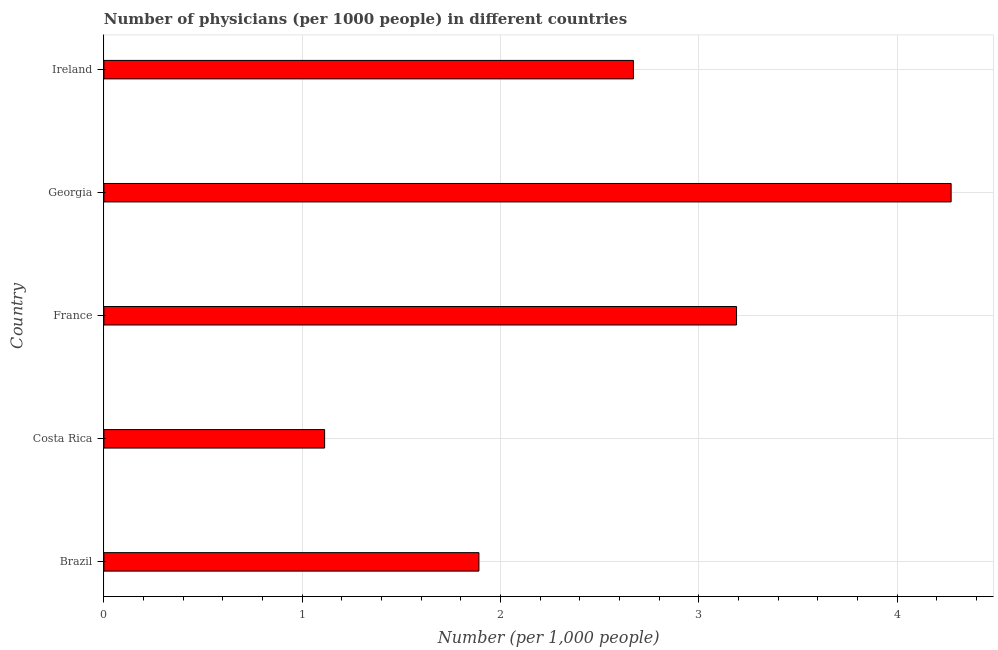What is the title of the graph?
Keep it short and to the point. Number of physicians (per 1000 people) in different countries. What is the label or title of the X-axis?
Your response must be concise. Number (per 1,0 people). What is the number of physicians in Brazil?
Your answer should be very brief. 1.89. Across all countries, what is the maximum number of physicians?
Make the answer very short. 4.27. Across all countries, what is the minimum number of physicians?
Ensure brevity in your answer.  1.11. In which country was the number of physicians maximum?
Provide a short and direct response. Georgia. In which country was the number of physicians minimum?
Provide a short and direct response. Costa Rica. What is the sum of the number of physicians?
Ensure brevity in your answer.  13.14. What is the difference between the number of physicians in Brazil and Georgia?
Offer a very short reply. -2.38. What is the average number of physicians per country?
Offer a very short reply. 2.63. What is the median number of physicians?
Ensure brevity in your answer.  2.67. What is the ratio of the number of physicians in Costa Rica to that in Georgia?
Make the answer very short. 0.26. Is the number of physicians in Georgia less than that in Ireland?
Provide a short and direct response. No. What is the difference between the highest and the second highest number of physicians?
Your answer should be compact. 1.08. Is the sum of the number of physicians in Brazil and Ireland greater than the maximum number of physicians across all countries?
Keep it short and to the point. Yes. What is the difference between the highest and the lowest number of physicians?
Offer a very short reply. 3.16. In how many countries, is the number of physicians greater than the average number of physicians taken over all countries?
Ensure brevity in your answer.  3. How many bars are there?
Your answer should be very brief. 5. Are all the bars in the graph horizontal?
Keep it short and to the point. Yes. How many countries are there in the graph?
Make the answer very short. 5. What is the difference between two consecutive major ticks on the X-axis?
Provide a short and direct response. 1. Are the values on the major ticks of X-axis written in scientific E-notation?
Make the answer very short. No. What is the Number (per 1,000 people) in Brazil?
Your answer should be compact. 1.89. What is the Number (per 1,000 people) in Costa Rica?
Provide a succinct answer. 1.11. What is the Number (per 1,000 people) of France?
Keep it short and to the point. 3.19. What is the Number (per 1,000 people) in Georgia?
Offer a terse response. 4.27. What is the Number (per 1,000 people) of Ireland?
Ensure brevity in your answer.  2.67. What is the difference between the Number (per 1,000 people) in Brazil and Costa Rica?
Keep it short and to the point. 0.78. What is the difference between the Number (per 1,000 people) in Brazil and France?
Provide a short and direct response. -1.3. What is the difference between the Number (per 1,000 people) in Brazil and Georgia?
Keep it short and to the point. -2.38. What is the difference between the Number (per 1,000 people) in Brazil and Ireland?
Provide a succinct answer. -0.78. What is the difference between the Number (per 1,000 people) in Costa Rica and France?
Your response must be concise. -2.08. What is the difference between the Number (per 1,000 people) in Costa Rica and Georgia?
Provide a short and direct response. -3.16. What is the difference between the Number (per 1,000 people) in Costa Rica and Ireland?
Your response must be concise. -1.56. What is the difference between the Number (per 1,000 people) in France and Georgia?
Your answer should be very brief. -1.08. What is the difference between the Number (per 1,000 people) in France and Ireland?
Keep it short and to the point. 0.52. What is the difference between the Number (per 1,000 people) in Georgia and Ireland?
Provide a succinct answer. 1.6. What is the ratio of the Number (per 1,000 people) in Brazil to that in Costa Rica?
Your answer should be compact. 1.7. What is the ratio of the Number (per 1,000 people) in Brazil to that in France?
Offer a very short reply. 0.59. What is the ratio of the Number (per 1,000 people) in Brazil to that in Georgia?
Provide a short and direct response. 0.44. What is the ratio of the Number (per 1,000 people) in Brazil to that in Ireland?
Offer a very short reply. 0.71. What is the ratio of the Number (per 1,000 people) in Costa Rica to that in France?
Offer a very short reply. 0.35. What is the ratio of the Number (per 1,000 people) in Costa Rica to that in Georgia?
Keep it short and to the point. 0.26. What is the ratio of the Number (per 1,000 people) in Costa Rica to that in Ireland?
Your answer should be very brief. 0.42. What is the ratio of the Number (per 1,000 people) in France to that in Georgia?
Provide a short and direct response. 0.75. What is the ratio of the Number (per 1,000 people) in France to that in Ireland?
Ensure brevity in your answer.  1.2. 